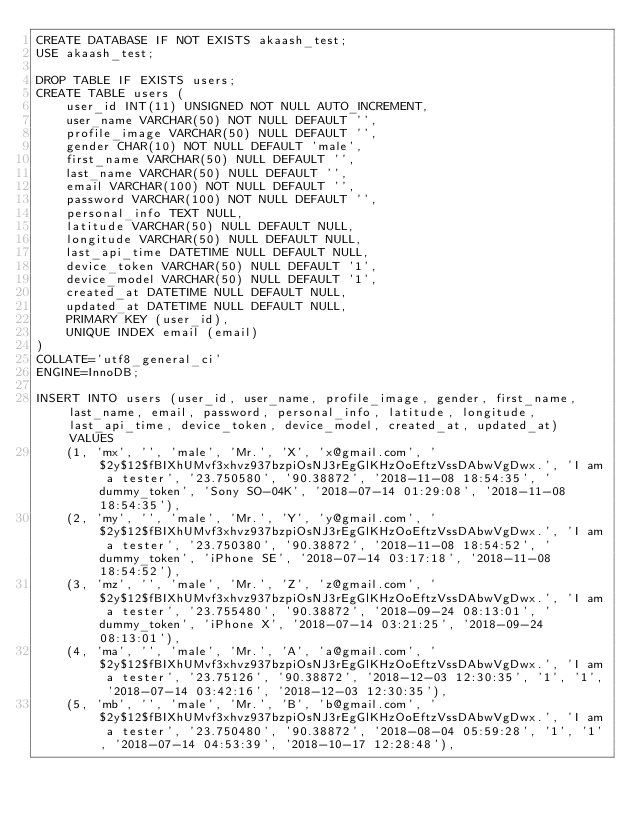<code> <loc_0><loc_0><loc_500><loc_500><_SQL_>CREATE DATABASE IF NOT EXISTS akaash_test;
USE akaash_test;

DROP TABLE IF EXISTS users;
CREATE TABLE users (
	user_id INT(11) UNSIGNED NOT NULL AUTO_INCREMENT,
	user_name VARCHAR(50) NOT NULL DEFAULT '',
	profile_image VARCHAR(50) NULL DEFAULT '',
	gender CHAR(10) NOT NULL DEFAULT 'male',
	first_name VARCHAR(50) NULL DEFAULT '',
	last_name VARCHAR(50) NULL DEFAULT '',
	email VARCHAR(100) NOT NULL DEFAULT '',
	password VARCHAR(100) NOT NULL DEFAULT '',
	personal_info TEXT NULL,
	latitude VARCHAR(50) NULL DEFAULT NULL,
	longitude VARCHAR(50) NULL DEFAULT NULL,
	last_api_time DATETIME NULL DEFAULT NULL,
	device_token VARCHAR(50) NULL DEFAULT '1',
	device_model VARCHAR(50) NULL DEFAULT '1',
	created_at DATETIME NULL DEFAULT NULL,
	updated_at DATETIME NULL DEFAULT NULL,
	PRIMARY KEY (user_id),
	UNIQUE INDEX email (email)
)
COLLATE='utf8_general_ci'
ENGINE=InnoDB;

INSERT INTO users (user_id, user_name, profile_image, gender, first_name, last_name, email, password, personal_info, latitude, longitude, last_api_time, device_token, device_model, created_at, updated_at) VALUES
	(1, 'mx', '', 'male', 'Mr.', 'X', 'x@gmail.com', '$2y$12$fBIXhUMvf3xhvz937bzpiOsNJ3rEgGlKHzOoEftzVssDAbwVgDwx.', 'I am a tester', '23.750580', '90.38872', '2018-11-08 18:54:35', 'dummy_token', 'Sony SO-04K', '2018-07-14 01:29:08', '2018-11-08 18:54:35'),
	(2, 'my', '', 'male', 'Mr.', 'Y', 'y@gmail.com', '$2y$12$fBIXhUMvf3xhvz937bzpiOsNJ3rEgGlKHzOoEftzVssDAbwVgDwx.', 'I am a tester', '23.750380', '90.38872', '2018-11-08 18:54:52', 'dummy_token', 'iPhone SE', '2018-07-14 03:17:18', '2018-11-08 18:54:52'),
	(3, 'mz', '', 'male', 'Mr.', 'Z', 'z@gmail.com', '$2y$12$fBIXhUMvf3xhvz937bzpiOsNJ3rEgGlKHzOoEftzVssDAbwVgDwx.', 'I am a tester', '23.755480', '90.38872', '2018-09-24 08:13:01', 'dummy_token', 'iPhone X', '2018-07-14 03:21:25', '2018-09-24 08:13:01'),
	(4, 'ma', '', 'male', 'Mr.', 'A', 'a@gmail.com', '$2y$12$fBIXhUMvf3xhvz937bzpiOsNJ3rEgGlKHzOoEftzVssDAbwVgDwx.', 'I am a tester', '23.75126', '90.38872', '2018-12-03 12:30:35', '1', '1', '2018-07-14 03:42:16', '2018-12-03 12:30:35'),
	(5, 'mb', '', 'male', 'Mr.', 'B', 'b@gmail.com', '$2y$12$fBIXhUMvf3xhvz937bzpiOsNJ3rEgGlKHzOoEftzVssDAbwVgDwx.', 'I am a tester', '23.750480', '90.38872', '2018-08-04 05:59:28', '1', '1', '2018-07-14 04:53:39', '2018-10-17 12:28:48'),</code> 